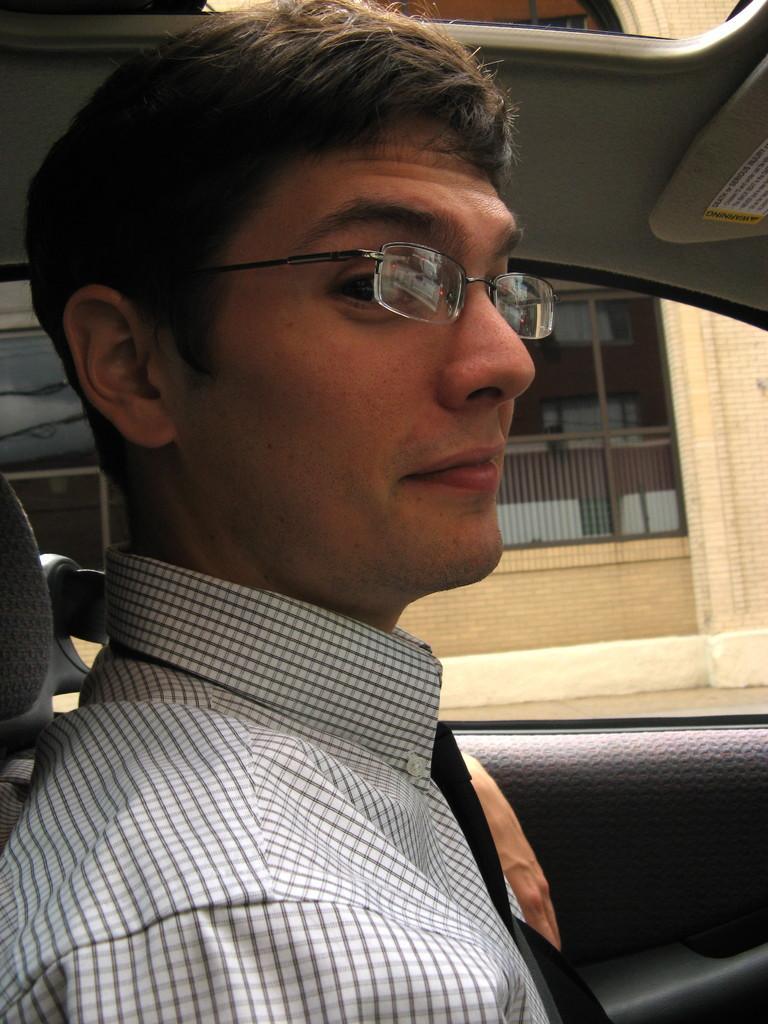Describe this image in one or two sentences. In this picture we can see a man sitting inside a vehicle. He wore spectacles. 